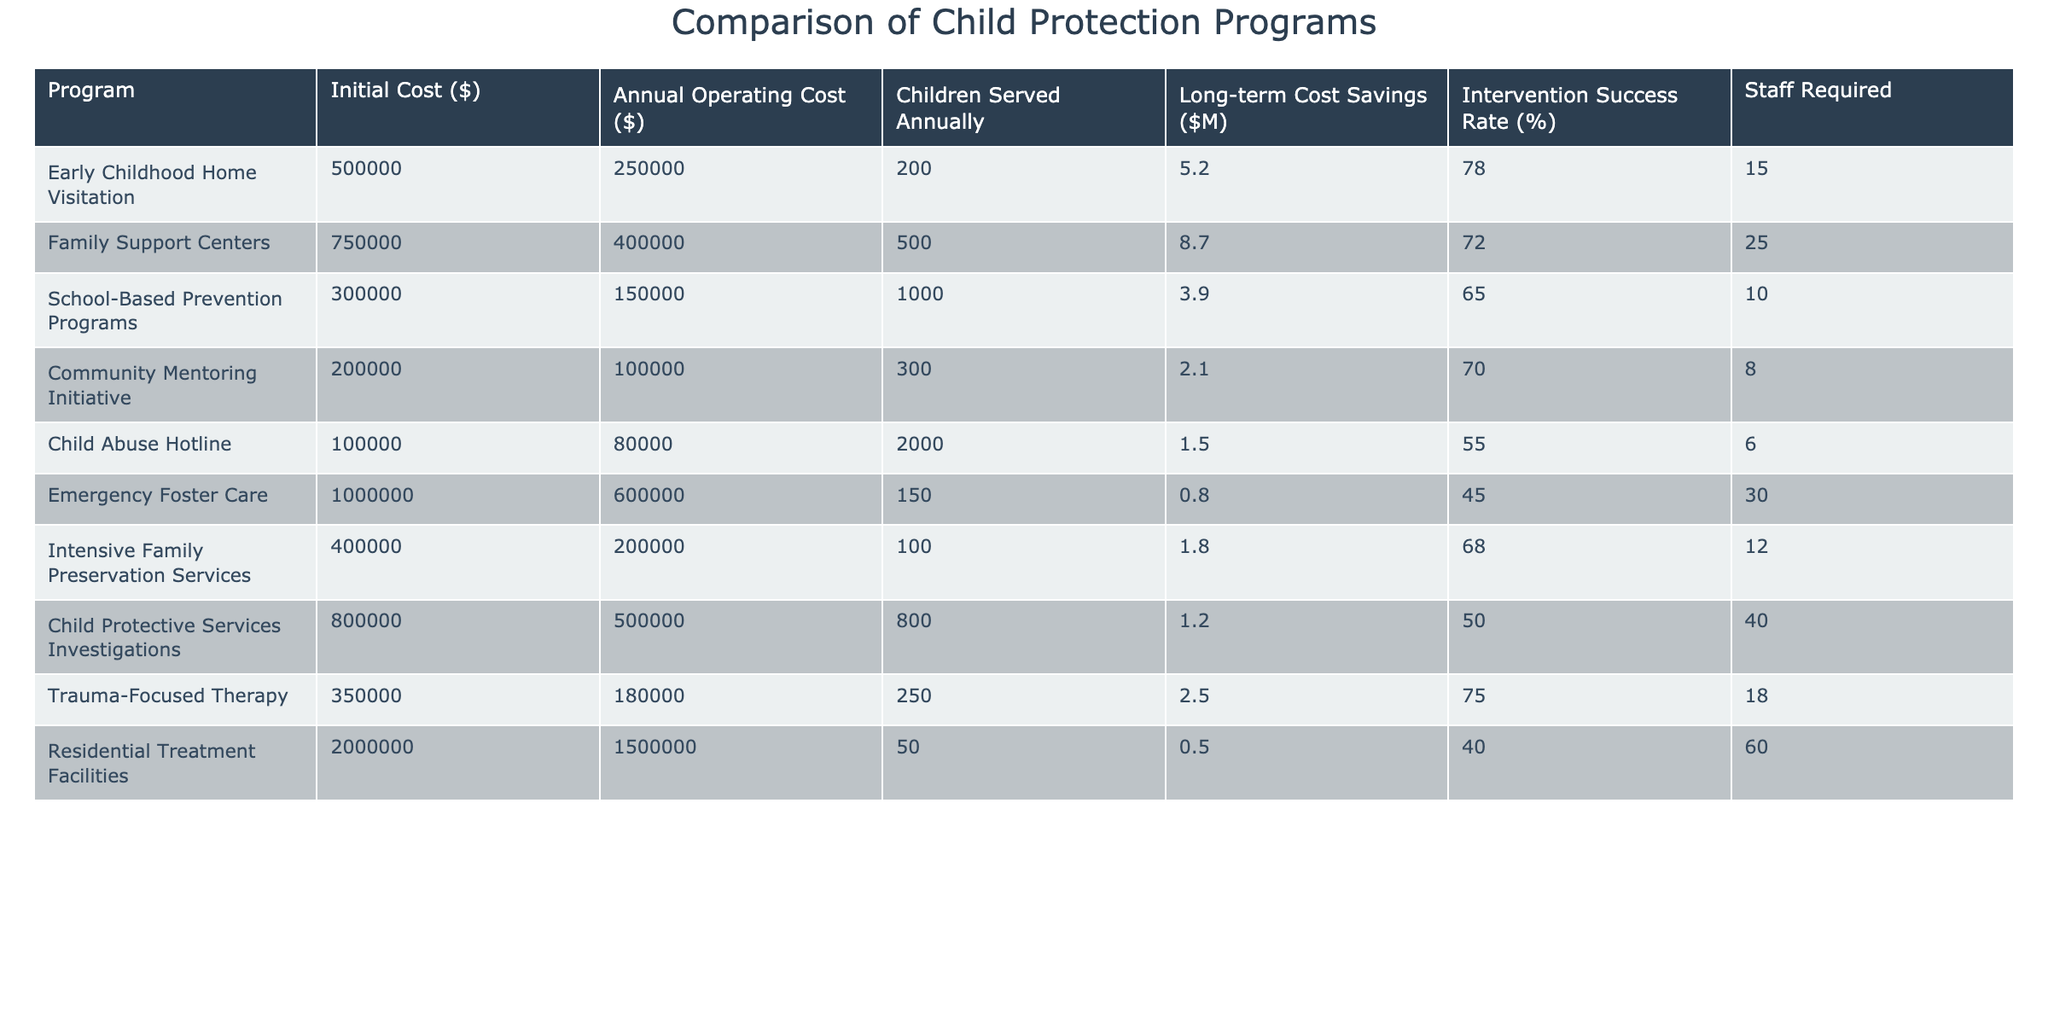What is the initial cost of the Intensive Family Preservation Services program? The table shows that the initial cost for Intensive Family Preservation Services is listed under the 'Initial Cost ($)' column. According to the data, this value is 400000.
Answer: 400000 How many children are served annually by the Family Support Centers program? To find the number of children served annually by the Family Support Centers program, we look for this program in the 'Children Served Annually' column. The provided data indicates that 500 children are served.
Answer: 500 Which program has the highest intervention success rate? The intervention success rate can be found in the 'Intervention Success Rate (%)' column. By comparing all rates, the Early Childhood Home Visitation program has the highest rate at 78%.
Answer: 78% What is the total long-term cost savings from the School-Based Prevention Programs and the Community Mentoring Initiative? The long-term cost savings for School-Based Prevention Programs is 3.9 million and for Community Mentoring Initiative it is 2.1 million. Adding these values gives: 3.9 + 2.1 = 6 million.
Answer: 6 million Is the Emergency Foster Care program more cost-effective in terms of long-term savings than the Child Abuse Hotline program? The long-term savings for Emergency Foster Care is 0.8 million, while for Child Abuse Hotline it is 1.5 million. Since 1.5 is greater than 0.8, Emergency Foster Care is not more cost-effective than the Child Abuse Hotline.
Answer: No What is the average number of children served annually across all the programs listed? To find the average, first sum the number of children served: 200 + 500 + 1000 + 300 + 2000 + 150 + 100 + 250 + 50 = 4350. Next, divide by the number of programs (9): 4350 / 9 ≈ 483.33. Thus, the average number of children served annually is approximately 483.33.
Answer: 483.33 Which program requires the most staff? The number of staff required for each program is in the 'Staff Required' column. By examining the data, Residential Treatment Facilities requires the most staff, listed as 60.
Answer: 60 Does any program have both high initial costs and a low intervention success rate? High initial costs can be considered as above 500000, while low intervention success can be defined as under 50%. The Emergency Foster Care program fits this description with an initial cost of 1000000 and a success rate of 45%.
Answer: Yes What is the difference in annual operating costs between the Family Support Centers and the Community Mentoring Initiative? The annual operating cost for Family Support Centers is 400000 and for the Community Mentoring Initiative is 100000. The difference is calculated as 400000 - 100000 = 300000.
Answer: 300000 